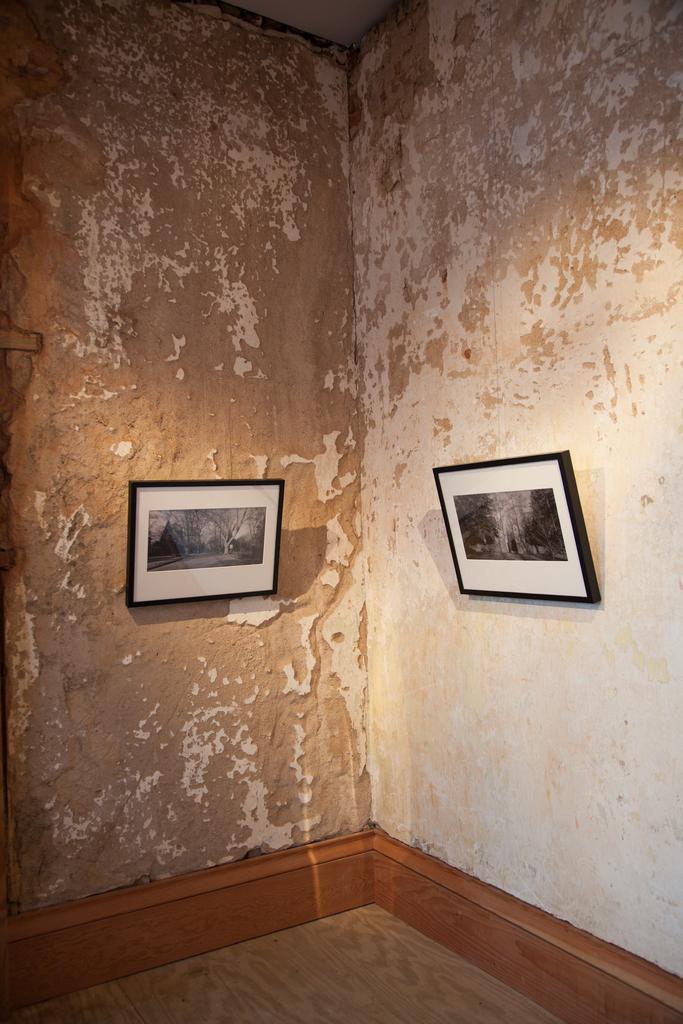In one or two sentences, can you explain what this image depicts? In this image I can see two photo frames on the wall. 